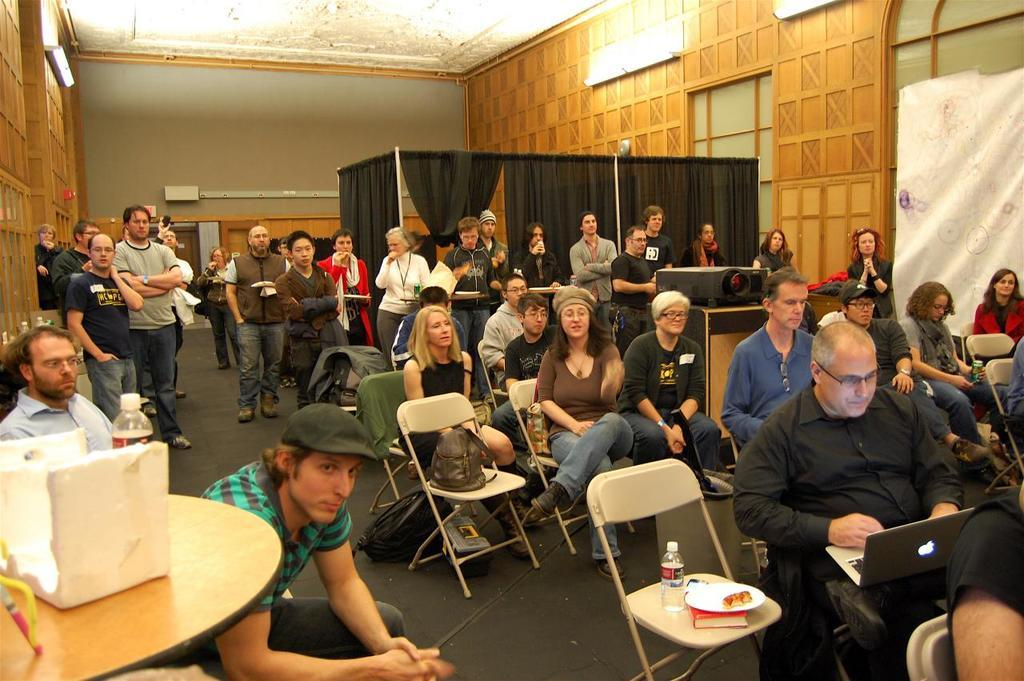What objects can be seen in the room? There are papers and people operating laptops in the room. How are the papers positioned in the room? Some papers are sitting, while others are standing. What is hanging in the room? There is a curtain hanging in the room. What type of kite is being used to write on the papers in the image? There is no kite present in the image; the papers are being used without any kites. Is there a quill visible in the image? There is no quill visible in the image; the people are operating laptops, not using quills. 